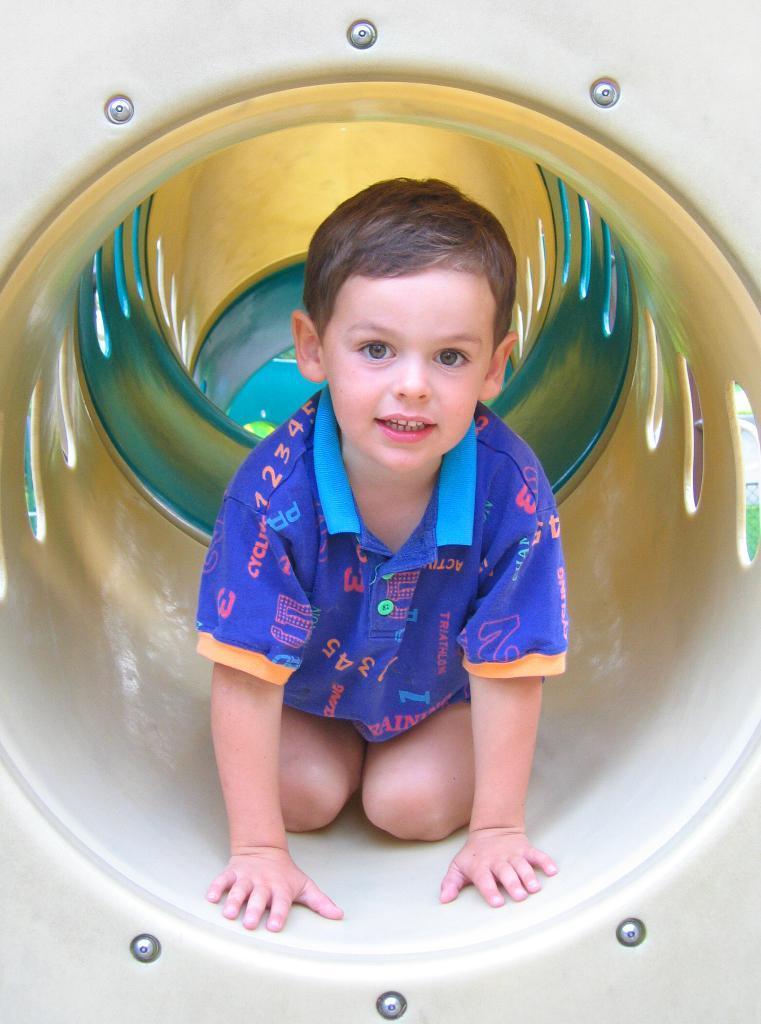How would you summarize this image in a sentence or two? In this image, we can see a kid inside tunnel. 